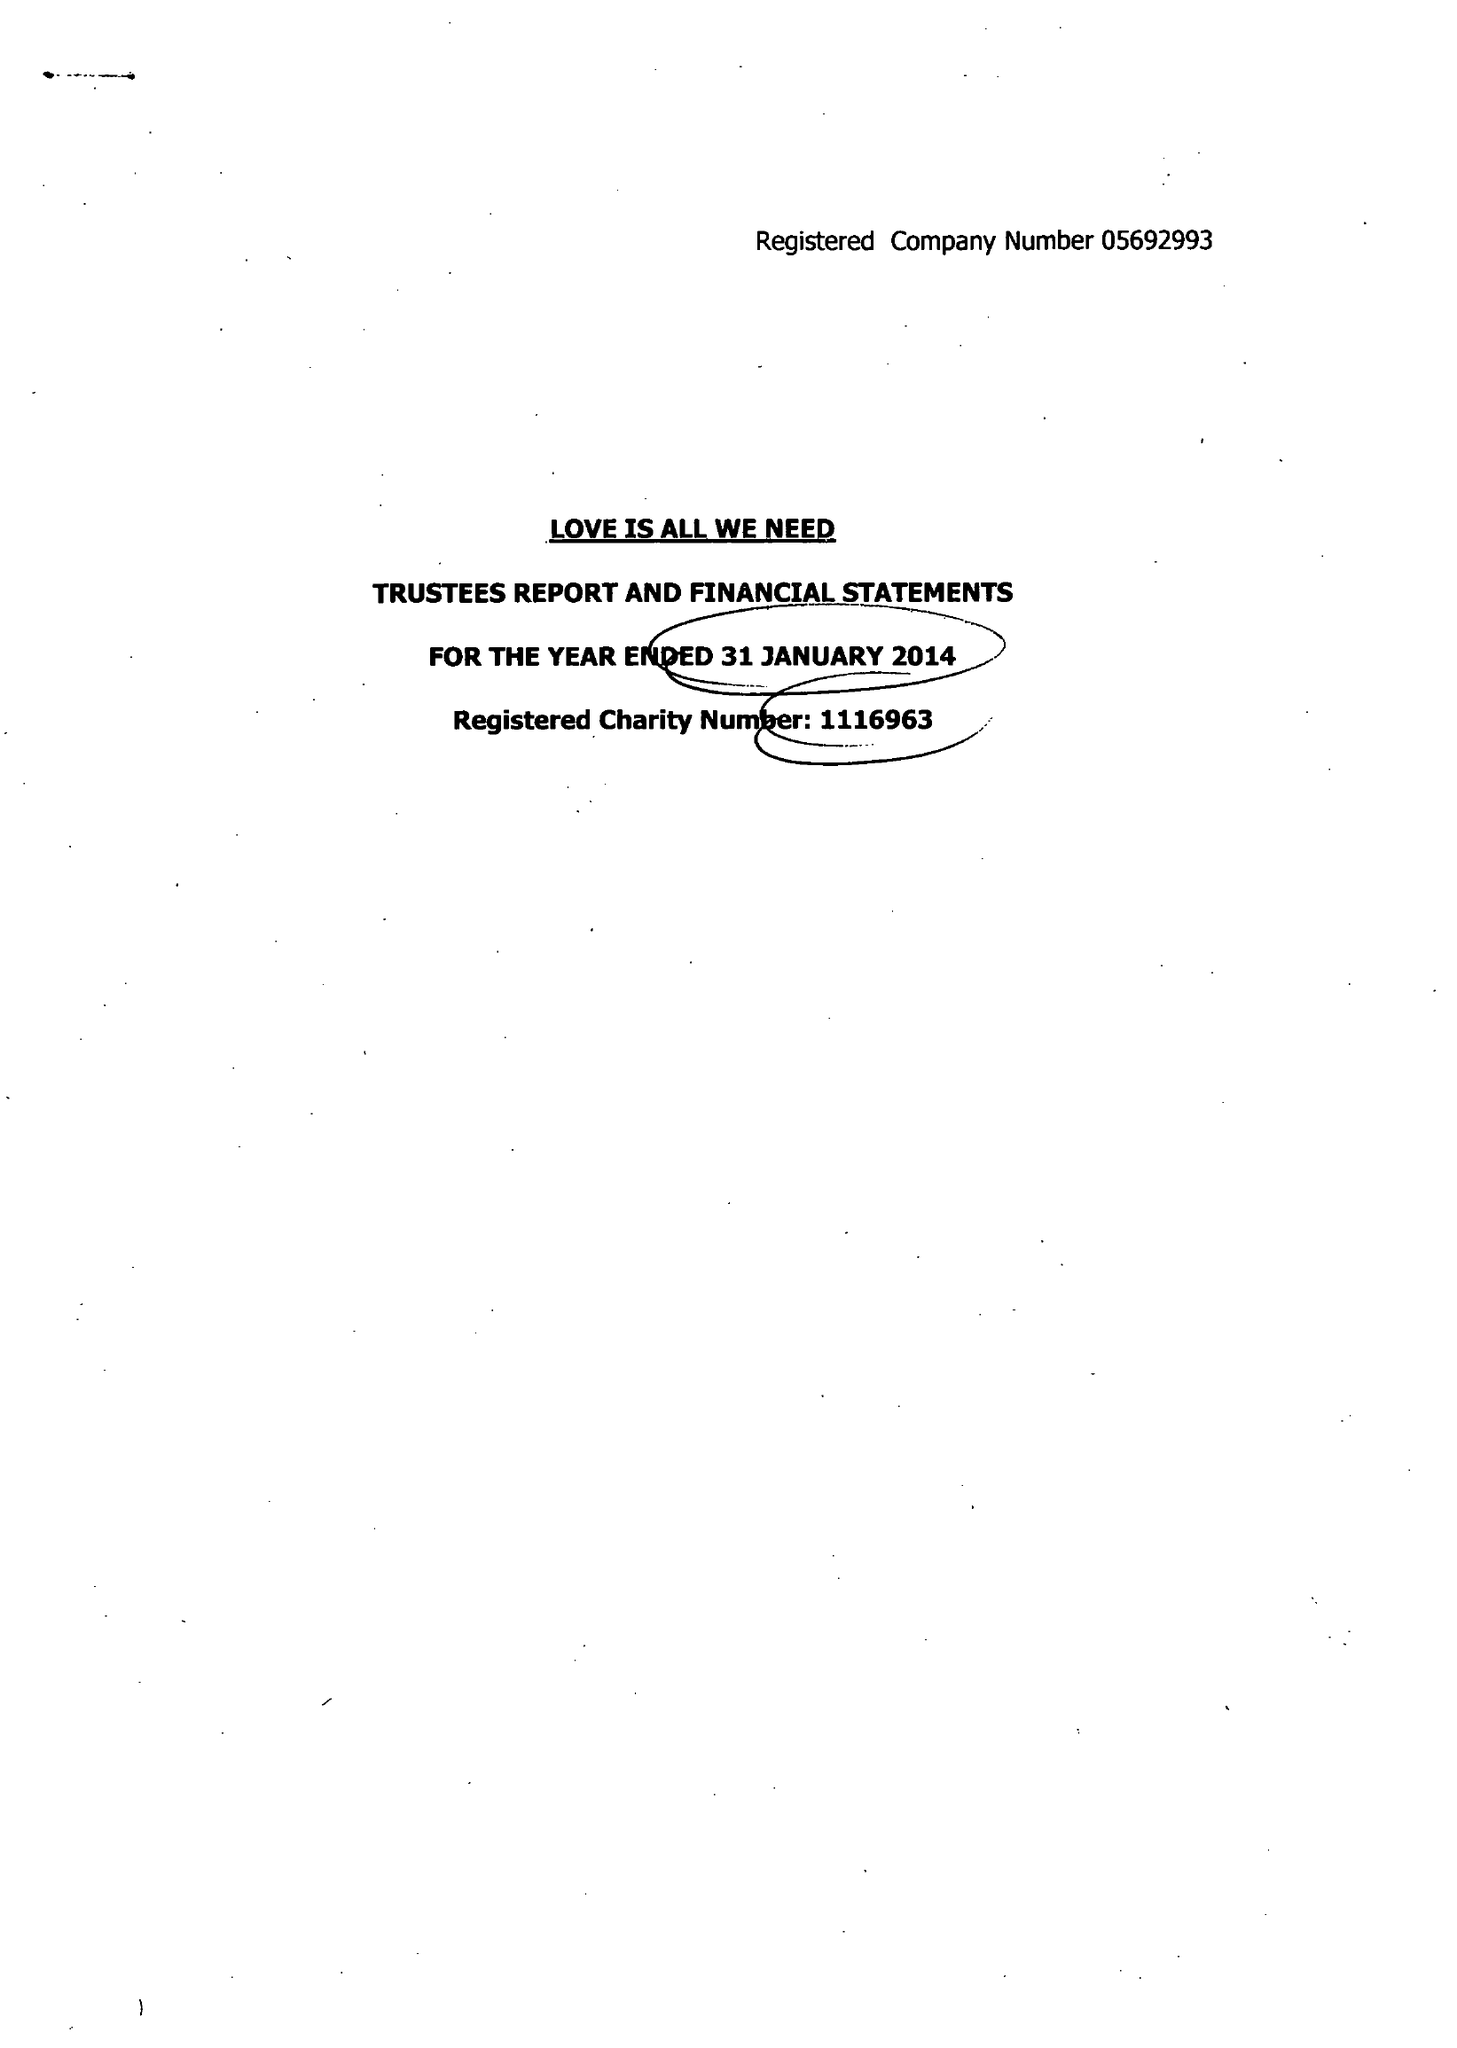What is the value for the charity_number?
Answer the question using a single word or phrase. 1116963 